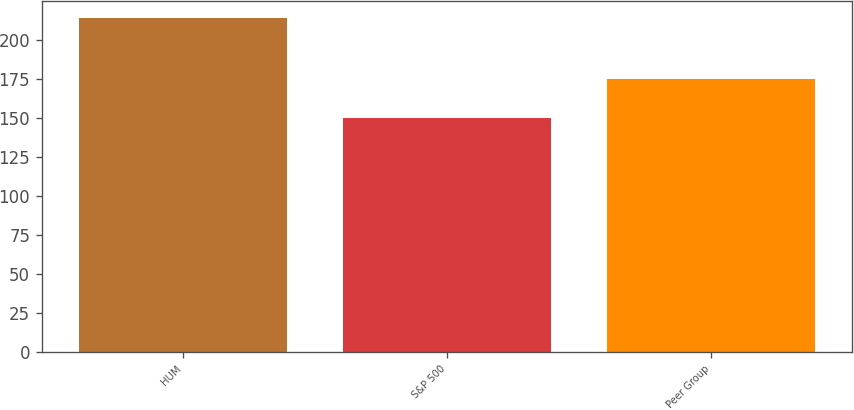<chart> <loc_0><loc_0><loc_500><loc_500><bar_chart><fcel>HUM<fcel>S&P 500<fcel>Peer Group<nl><fcel>214<fcel>150<fcel>175<nl></chart> 